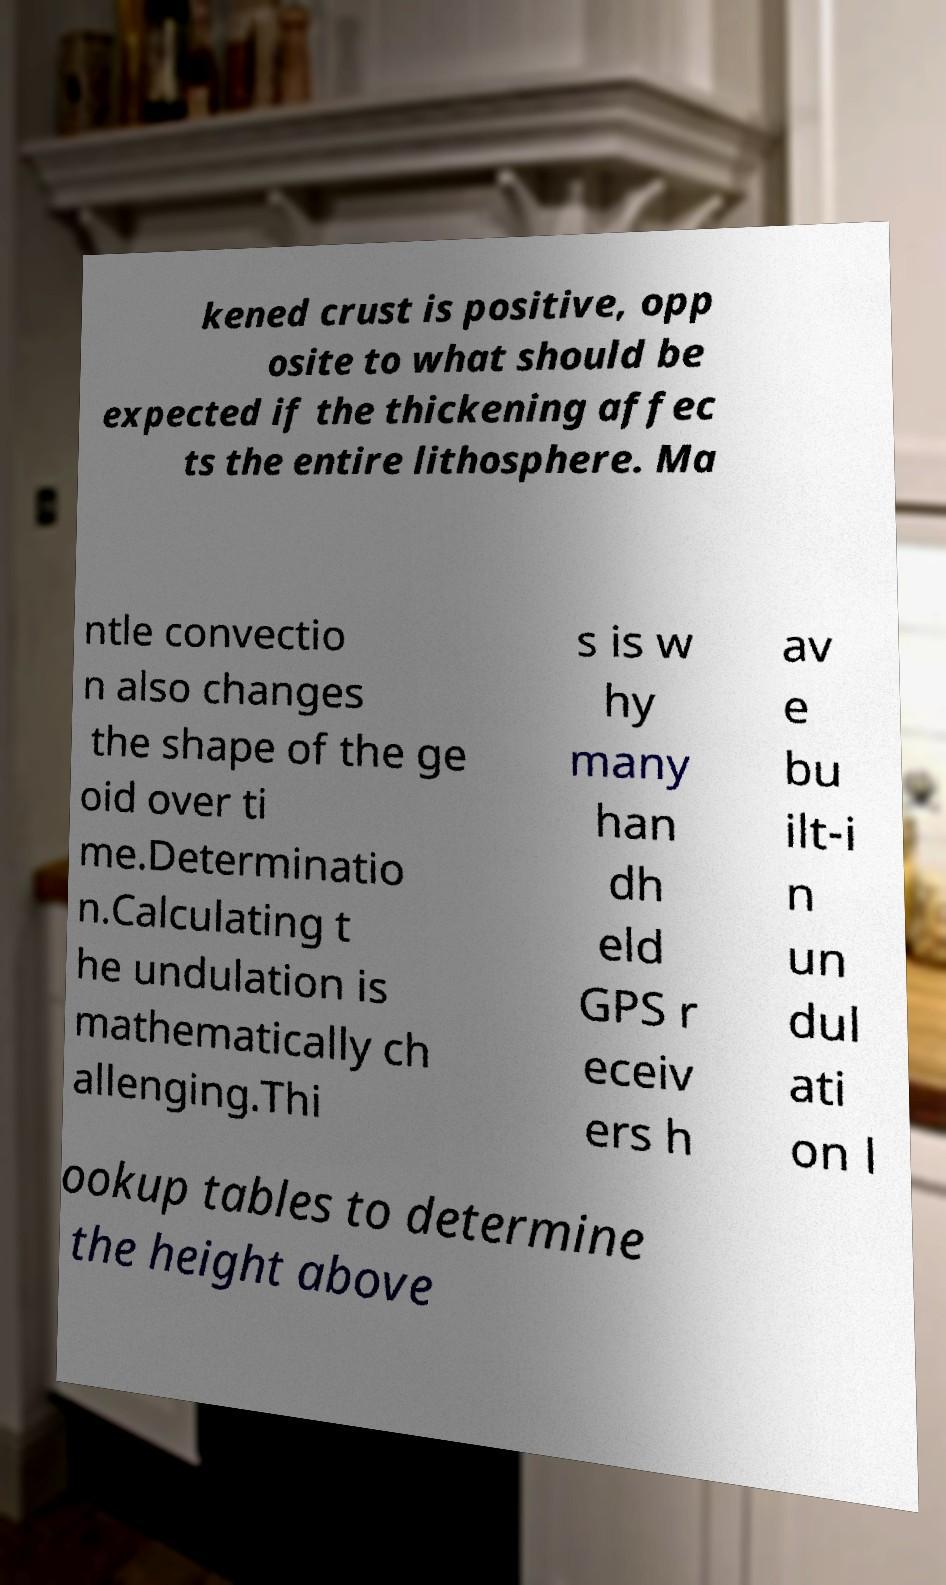Could you extract and type out the text from this image? kened crust is positive, opp osite to what should be expected if the thickening affec ts the entire lithosphere. Ma ntle convectio n also changes the shape of the ge oid over ti me.Determinatio n.Calculating t he undulation is mathematically ch allenging.Thi s is w hy many han dh eld GPS r eceiv ers h av e bu ilt-i n un dul ati on l ookup tables to determine the height above 